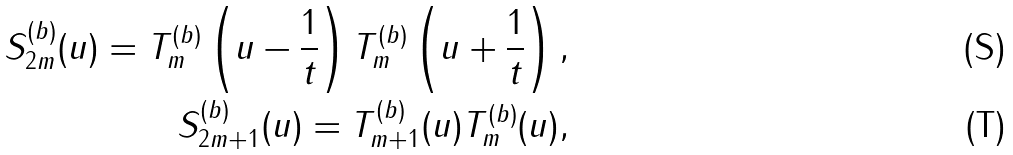<formula> <loc_0><loc_0><loc_500><loc_500>S ^ { ( b ) } _ { 2 m } ( u ) = T ^ { ( b ) } _ { m } \left ( u - \frac { 1 } { t } \right ) T ^ { ( b ) } _ { m } \left ( u + \frac { 1 } { t } \right ) , \\ S ^ { ( b ) } _ { 2 m + 1 } ( u ) = T ^ { ( b ) } _ { m + 1 } ( u ) T ^ { ( b ) } _ { m } ( u ) ,</formula> 